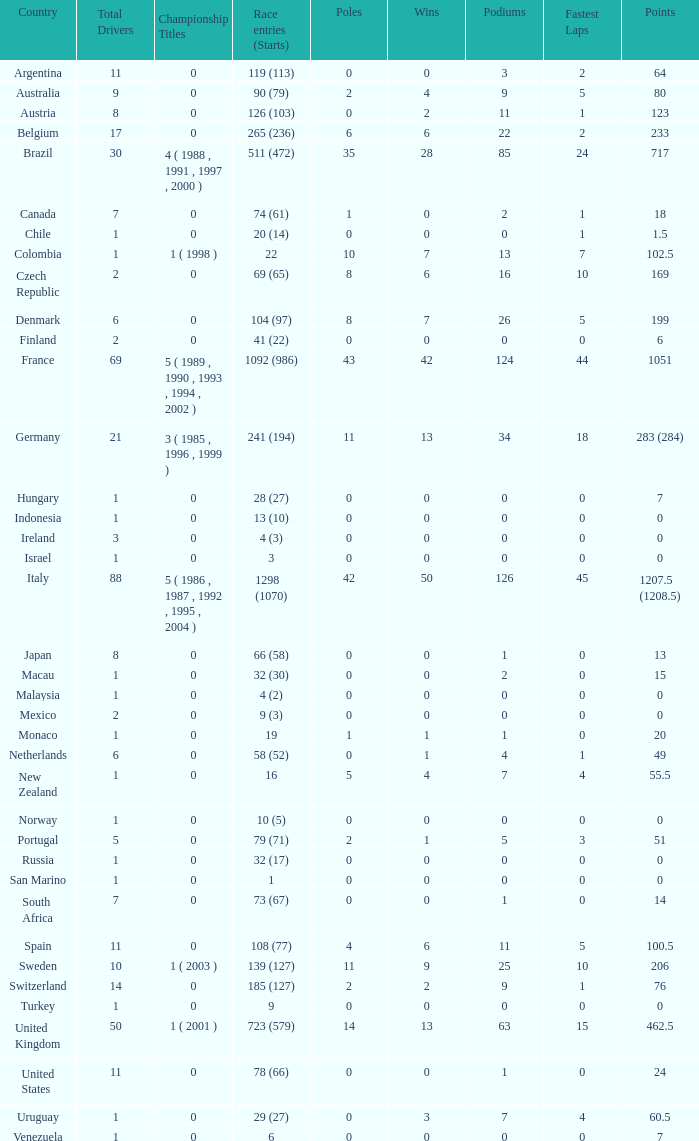How many titles for the nation with less than 3 fastest laps and 22 podiums? 0.0. 